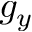<formula> <loc_0><loc_0><loc_500><loc_500>g _ { y }</formula> 